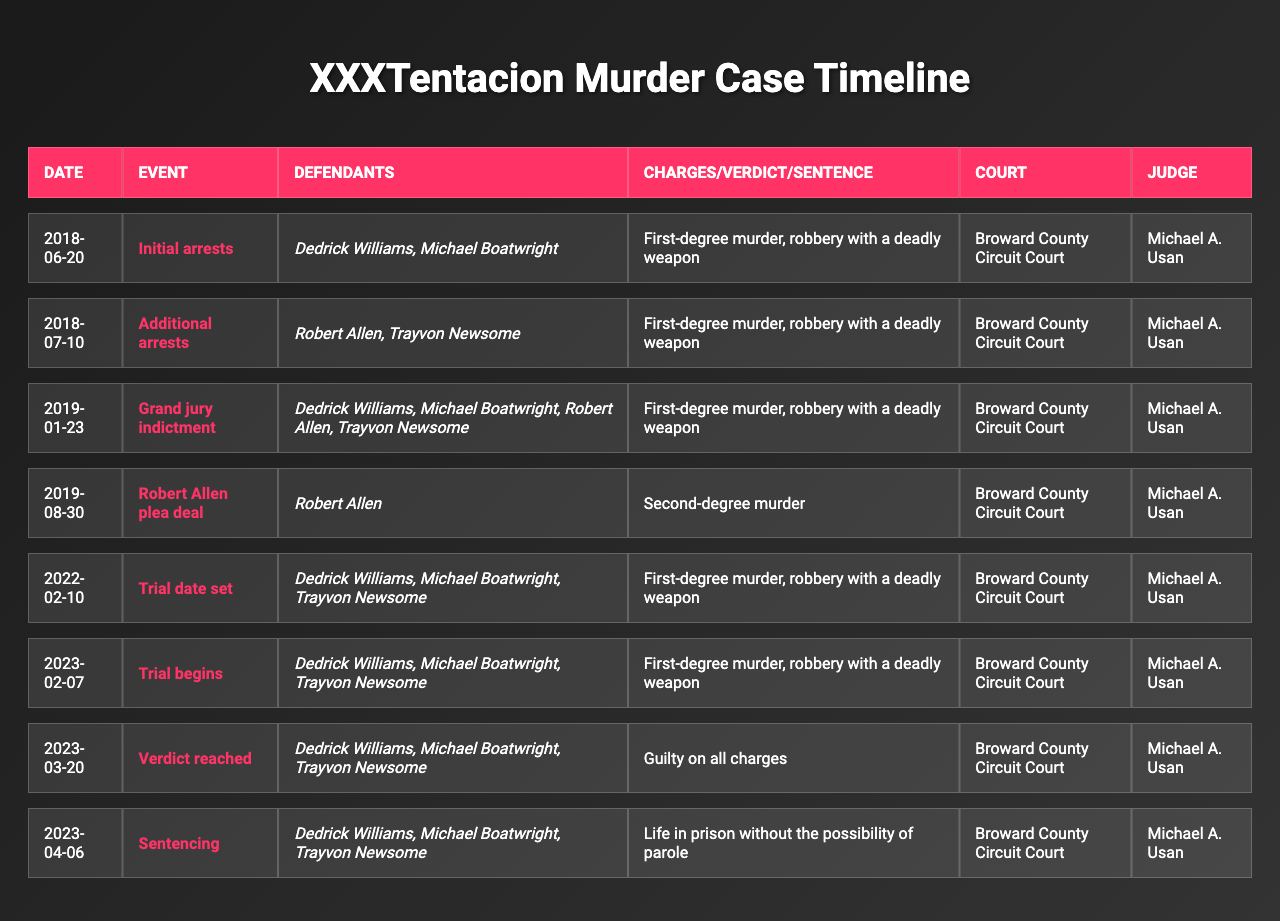What event took place on February 7, 2023? The table shows that the event on that date was the start of the trial for Dedrick Williams, Michael Boatwright, and Trayvon Newsome, related to first-degree murder and robbery with a deadly weapon.
Answer: Trial begins Who was sentenced to life in prison without parole? According to the table, Dedrick Williams, Michael Boatwright, and Trayvon Newsome were all sentenced to life in prison without the possibility of parole following their verdict.
Answer: Dedrick Williams, Michael Boatwright, Trayvon Newsome How many total arrests were made in connection with XXXTentacion's murder case? There were two initial arrests on June 20, 2018, followed by two additional arrests on July 10, 2018, making a total of four arrests.
Answer: Four arrests What charge did Robert Allen plead guilty to? The table indicates that Robert Allen struck a plea deal for the charge of second-degree murder on August 30, 2019.
Answer: Second-degree murder Which judge presided over all court events listed in the table? All events in the table were presided over by Judge Michael A. Usan as stated in each row of the table.
Answer: Michael A. Usan What was the verdict reached on March 20, 2023? The table shows that on that date, the verdict reached was guilty on all charges for the defendants Dedrick Williams, Michael Boatwright, and Trayvon Newsome.
Answer: Guilty on all charges Were the charges the same for all defendants during the grand jury indictment? Yes, the table indicates that all defendants (Dedrick Williams, Michael Boatwright, Robert Allen, and Trayvon Newsome) faced the same charges of first-degree murder and robbery with a deadly weapon during the grand jury indictment.
Answer: Yes How many months passed between the initial arrests and the grand jury indictment? The initial arrests occurred on June 20, 2018, and the grand jury indictment was on January 23, 2019. Calculating the months, that is about 7 months.
Answer: 7 months Which event occurred before Robert Allen's plea deal? The event that occurred before Robert Allen's plea deal on August 30, 2019, was the grand jury indictment on January 23, 2019.
Answer: Grand jury indictment What is the difference between the charges at the initial arrests and the charges at the plea deal by Robert Allen? The initial arrests involved charges of first-degree murder and robbery with a deadly weapon, while Robert Allen's plea deal involved a charge of second-degree murder, indicating a lesser charge.
Answer: First-degree murder vs. second-degree murder Did the trial begin before or after the trial date was set? The trial began on February 7, 2023, which is after the trial date was set on February 10, 2022, indicating that the trial commenced later than when it was originally scheduled.
Answer: After 